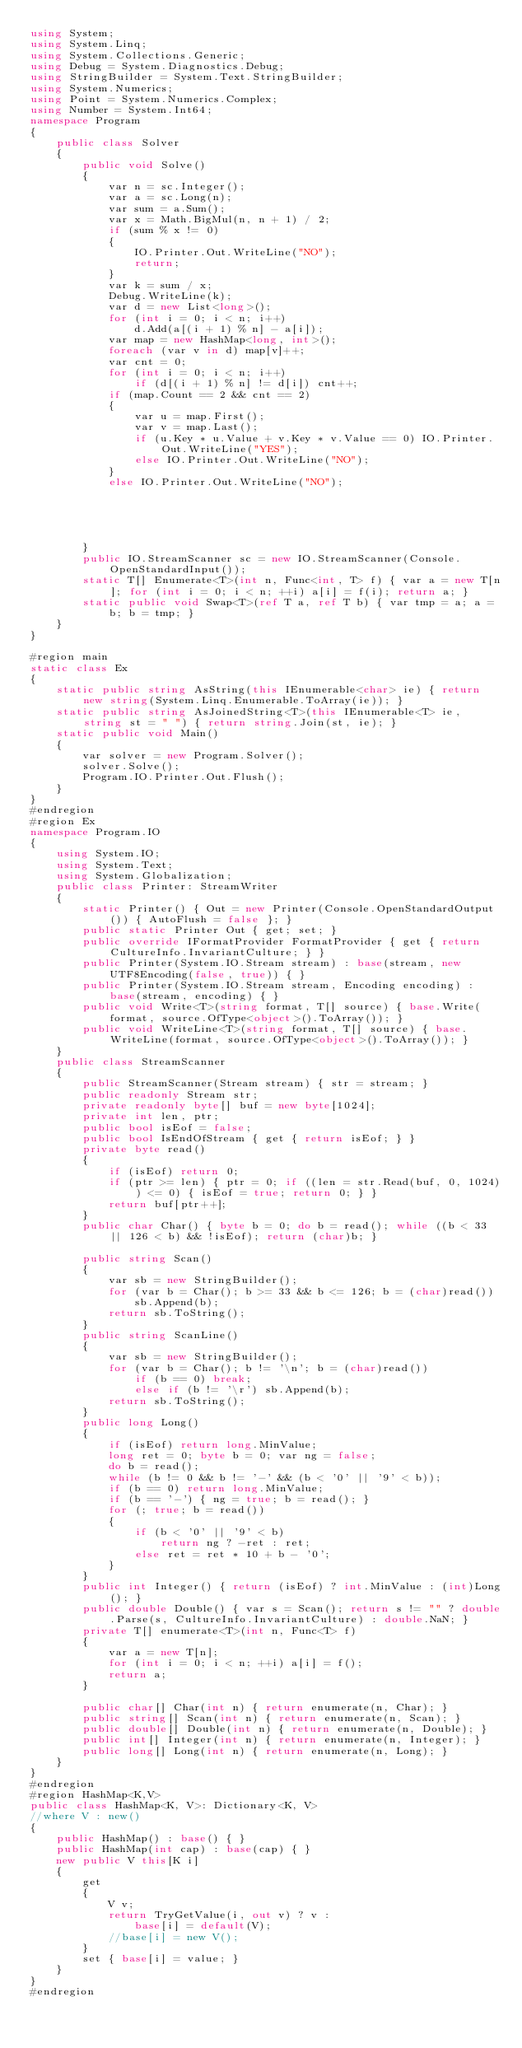Convert code to text. <code><loc_0><loc_0><loc_500><loc_500><_C#_>using System;
using System.Linq;
using System.Collections.Generic;
using Debug = System.Diagnostics.Debug;
using StringBuilder = System.Text.StringBuilder;
using System.Numerics;
using Point = System.Numerics.Complex;
using Number = System.Int64;
namespace Program
{
    public class Solver
    {
        public void Solve()
        {
            var n = sc.Integer();
            var a = sc.Long(n);
            var sum = a.Sum();
            var x = Math.BigMul(n, n + 1) / 2;
            if (sum % x != 0)
            {
                IO.Printer.Out.WriteLine("NO");
                return;
            }
            var k = sum / x;
            Debug.WriteLine(k);
            var d = new List<long>();
            for (int i = 0; i < n; i++)
                d.Add(a[(i + 1) % n] - a[i]);
            var map = new HashMap<long, int>();
            foreach (var v in d) map[v]++;
            var cnt = 0;
            for (int i = 0; i < n; i++)
                if (d[(i + 1) % n] != d[i]) cnt++;
            if (map.Count == 2 && cnt == 2)
            {
                var u = map.First();
                var v = map.Last();
                if (u.Key * u.Value + v.Key * v.Value == 0) IO.Printer.Out.WriteLine("YES");
                else IO.Printer.Out.WriteLine("NO");
            }
            else IO.Printer.Out.WriteLine("NO");





        }
        public IO.StreamScanner sc = new IO.StreamScanner(Console.OpenStandardInput());
        static T[] Enumerate<T>(int n, Func<int, T> f) { var a = new T[n]; for (int i = 0; i < n; ++i) a[i] = f(i); return a; }
        static public void Swap<T>(ref T a, ref T b) { var tmp = a; a = b; b = tmp; }
    }
}

#region main
static class Ex
{
    static public string AsString(this IEnumerable<char> ie) { return new string(System.Linq.Enumerable.ToArray(ie)); }
    static public string AsJoinedString<T>(this IEnumerable<T> ie, string st = " ") { return string.Join(st, ie); }
    static public void Main()
    {
        var solver = new Program.Solver();
        solver.Solve();
        Program.IO.Printer.Out.Flush();
    }
}
#endregion
#region Ex
namespace Program.IO
{
    using System.IO;
    using System.Text;
    using System.Globalization;
    public class Printer: StreamWriter
    {
        static Printer() { Out = new Printer(Console.OpenStandardOutput()) { AutoFlush = false }; }
        public static Printer Out { get; set; }
        public override IFormatProvider FormatProvider { get { return CultureInfo.InvariantCulture; } }
        public Printer(System.IO.Stream stream) : base(stream, new UTF8Encoding(false, true)) { }
        public Printer(System.IO.Stream stream, Encoding encoding) : base(stream, encoding) { }
        public void Write<T>(string format, T[] source) { base.Write(format, source.OfType<object>().ToArray()); }
        public void WriteLine<T>(string format, T[] source) { base.WriteLine(format, source.OfType<object>().ToArray()); }
    }
    public class StreamScanner
    {
        public StreamScanner(Stream stream) { str = stream; }
        public readonly Stream str;
        private readonly byte[] buf = new byte[1024];
        private int len, ptr;
        public bool isEof = false;
        public bool IsEndOfStream { get { return isEof; } }
        private byte read()
        {
            if (isEof) return 0;
            if (ptr >= len) { ptr = 0; if ((len = str.Read(buf, 0, 1024)) <= 0) { isEof = true; return 0; } }
            return buf[ptr++];
        }
        public char Char() { byte b = 0; do b = read(); while ((b < 33 || 126 < b) && !isEof); return (char)b; }

        public string Scan()
        {
            var sb = new StringBuilder();
            for (var b = Char(); b >= 33 && b <= 126; b = (char)read())
                sb.Append(b);
            return sb.ToString();
        }
        public string ScanLine()
        {
            var sb = new StringBuilder();
            for (var b = Char(); b != '\n'; b = (char)read())
                if (b == 0) break;
                else if (b != '\r') sb.Append(b);
            return sb.ToString();
        }
        public long Long()
        {
            if (isEof) return long.MinValue;
            long ret = 0; byte b = 0; var ng = false;
            do b = read();
            while (b != 0 && b != '-' && (b < '0' || '9' < b));
            if (b == 0) return long.MinValue;
            if (b == '-') { ng = true; b = read(); }
            for (; true; b = read())
            {
                if (b < '0' || '9' < b)
                    return ng ? -ret : ret;
                else ret = ret * 10 + b - '0';
            }
        }
        public int Integer() { return (isEof) ? int.MinValue : (int)Long(); }
        public double Double() { var s = Scan(); return s != "" ? double.Parse(s, CultureInfo.InvariantCulture) : double.NaN; }
        private T[] enumerate<T>(int n, Func<T> f)
        {
            var a = new T[n];
            for (int i = 0; i < n; ++i) a[i] = f();
            return a;
        }

        public char[] Char(int n) { return enumerate(n, Char); }
        public string[] Scan(int n) { return enumerate(n, Scan); }
        public double[] Double(int n) { return enumerate(n, Double); }
        public int[] Integer(int n) { return enumerate(n, Integer); }
        public long[] Long(int n) { return enumerate(n, Long); }
    }
}
#endregion
#region HashMap<K,V>
public class HashMap<K, V>: Dictionary<K, V>
//where V : new()
{
    public HashMap() : base() { }
    public HashMap(int cap) : base(cap) { }
    new public V this[K i]
    {
        get
        {
            V v;
            return TryGetValue(i, out v) ? v :
                base[i] = default(V);
            //base[i] = new V();
        }
        set { base[i] = value; }
    }
}
#endregion</code> 